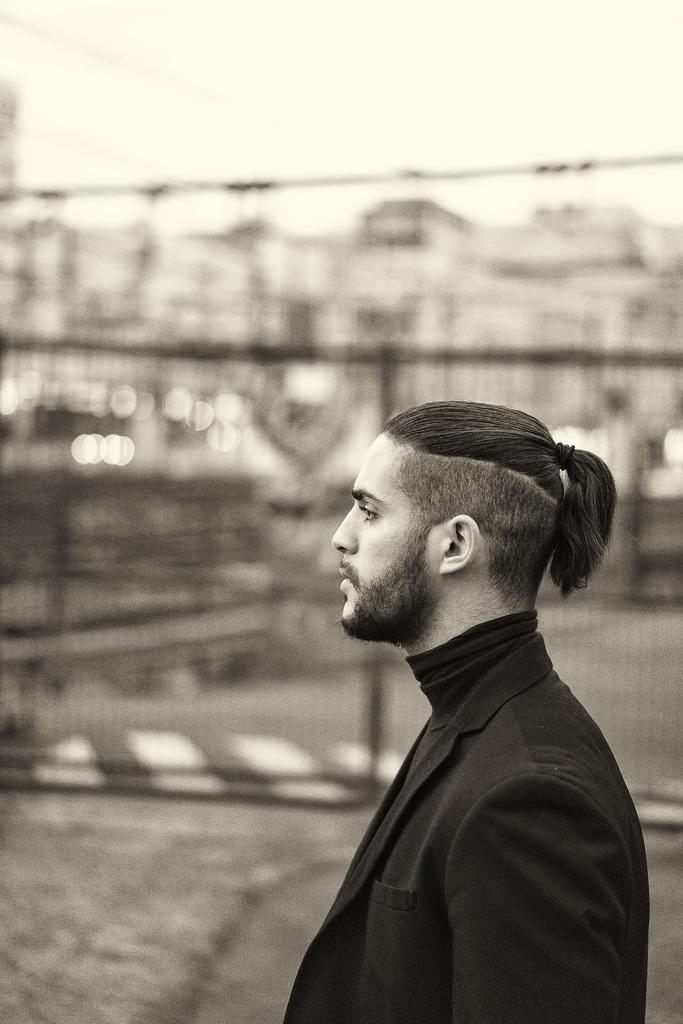What is the main subject of the image? There is a person standing in the image. What is the person wearing? The person is wearing a black suit. What color scheme is used in the image? The image is in black and white color. What type of skin condition can be seen on the person's face in the image? There is no skin condition visible on the person's face in the image, as the image is in black and white color. How many options were available for the person to choose from when selecting their outfit for the image? The provided facts do not mention any options or selection process for the person's outfit, so it cannot be determined from the image. 